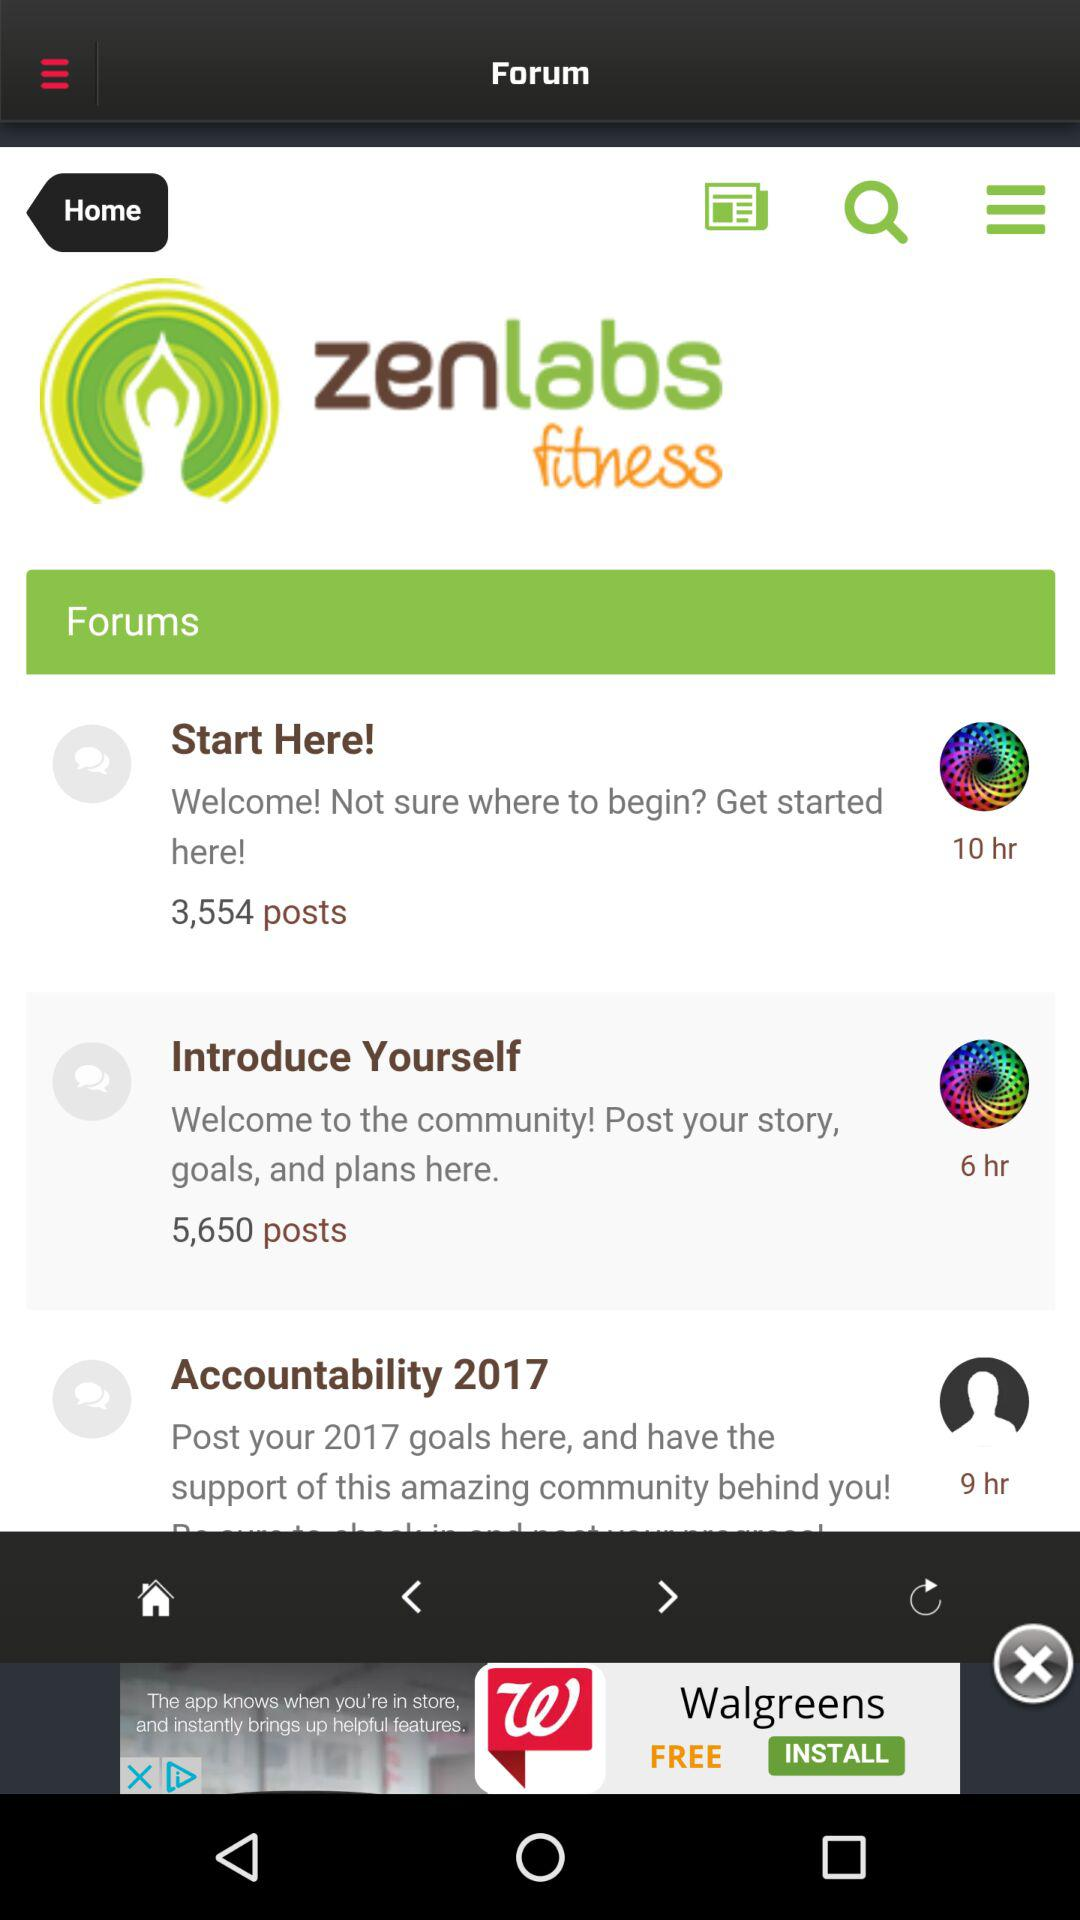How many posts are there in the forum named "Introduce Yourself"? There are 5,650 posts. 